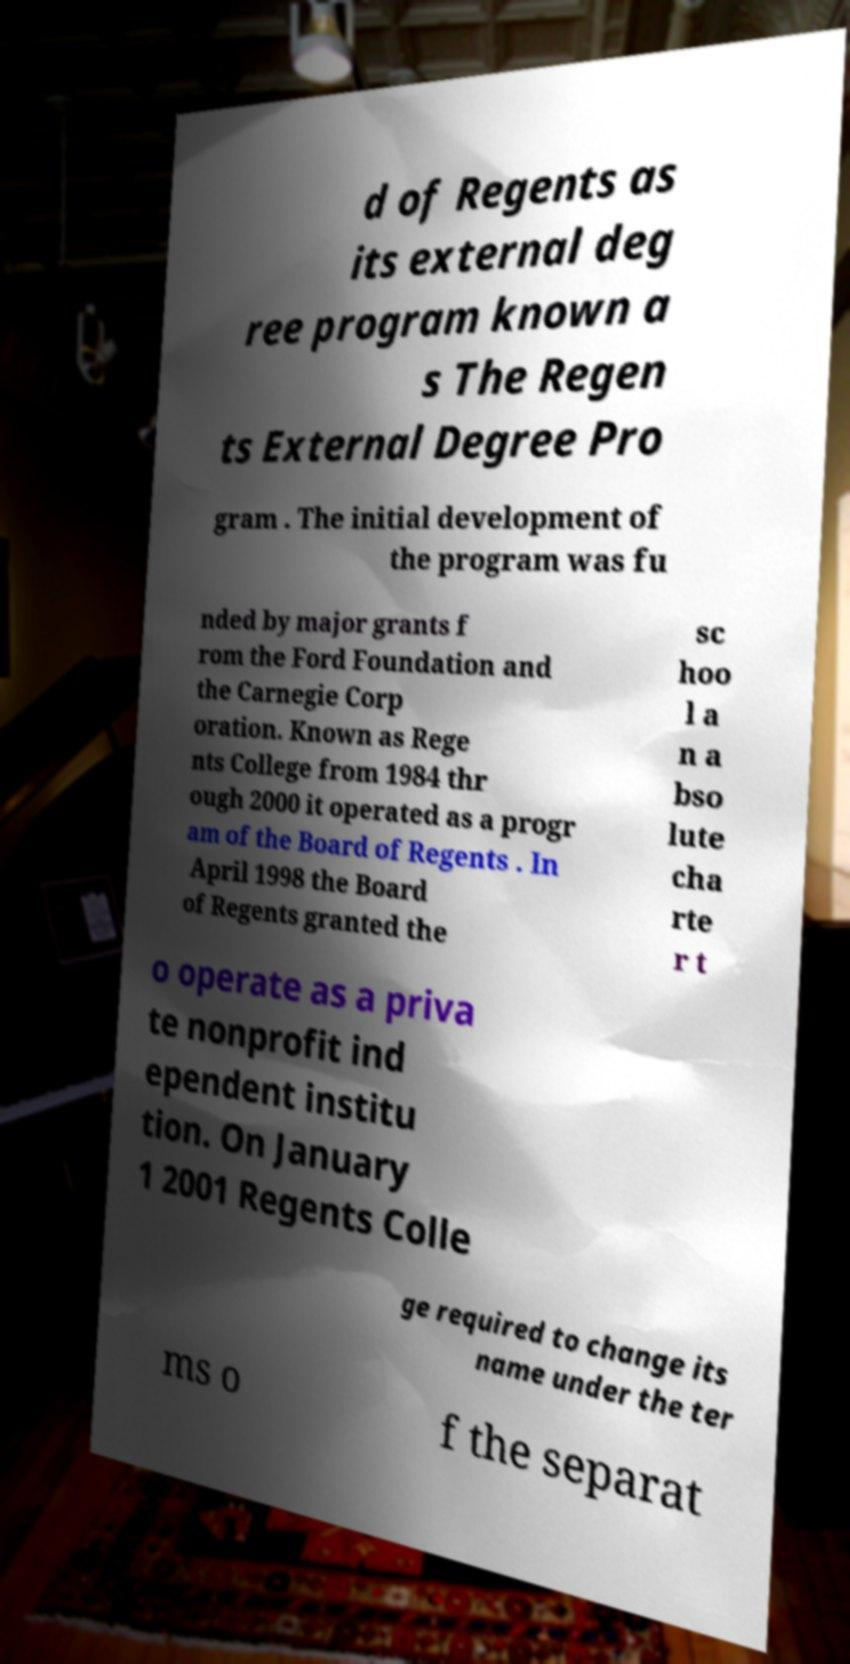Can you accurately transcribe the text from the provided image for me? d of Regents as its external deg ree program known a s The Regen ts External Degree Pro gram . The initial development of the program was fu nded by major grants f rom the Ford Foundation and the Carnegie Corp oration. Known as Rege nts College from 1984 thr ough 2000 it operated as a progr am of the Board of Regents . In April 1998 the Board of Regents granted the sc hoo l a n a bso lute cha rte r t o operate as a priva te nonprofit ind ependent institu tion. On January 1 2001 Regents Colle ge required to change its name under the ter ms o f the separat 